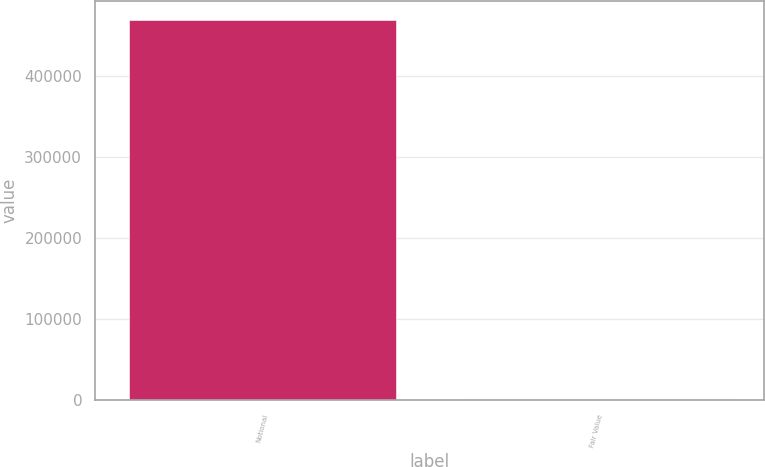<chart> <loc_0><loc_0><loc_500><loc_500><bar_chart><fcel>Notional<fcel>Fair Value<nl><fcel>469354<fcel>939<nl></chart> 